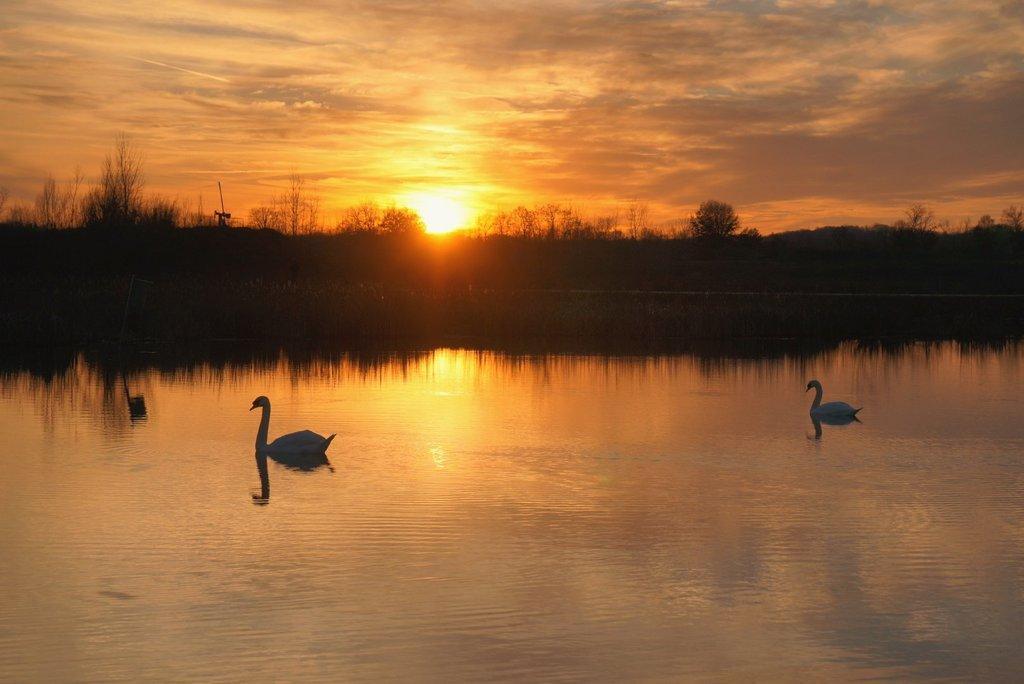In one or two sentences, can you explain what this image depicts? In the foreground of the picture there is a water body, in the water there are swans. In the center of the picture there are trees. In the background it is sun in the sky. 